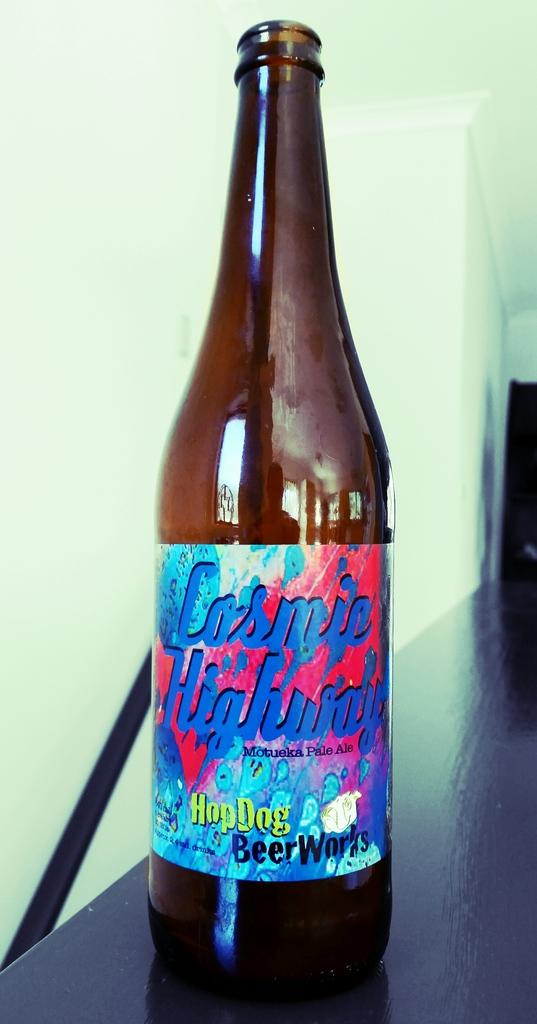Provide a one-sentence caption for the provided image. Bottle of beer with a label that says HopDog Beer Works. 